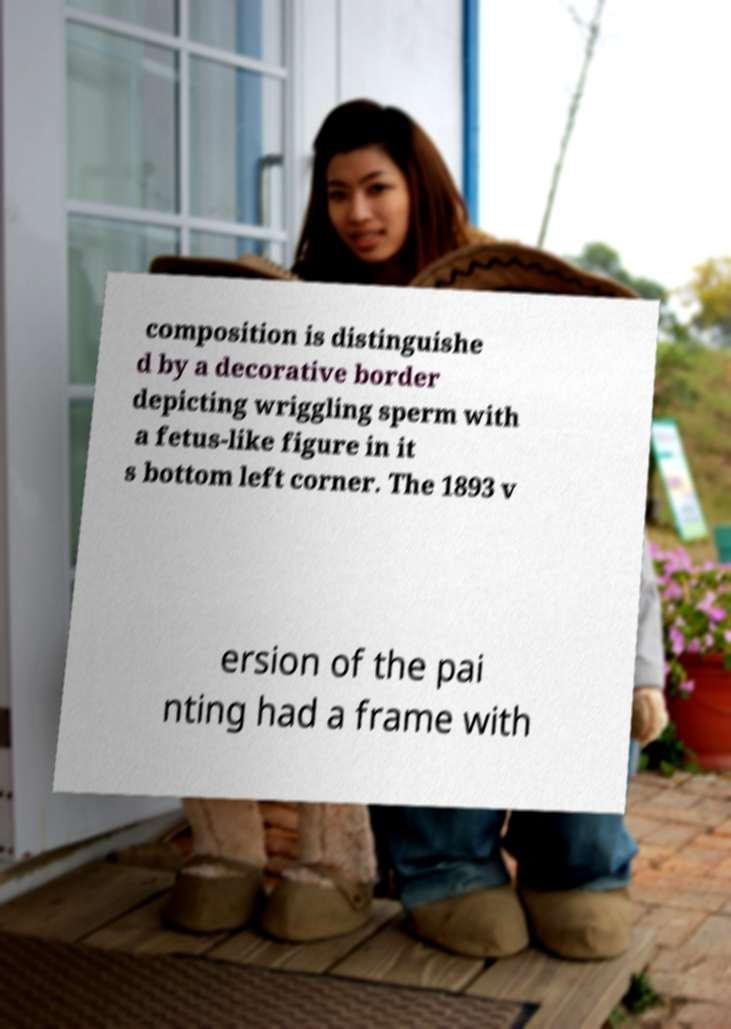For documentation purposes, I need the text within this image transcribed. Could you provide that? composition is distinguishe d by a decorative border depicting wriggling sperm with a fetus-like figure in it s bottom left corner. The 1893 v ersion of the pai nting had a frame with 